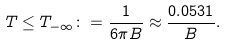<formula> <loc_0><loc_0><loc_500><loc_500>T \leq T _ { - \infty } \colon = \frac { 1 } { 6 \pi B } \approx \frac { 0 . 0 5 3 1 } { B } .</formula> 